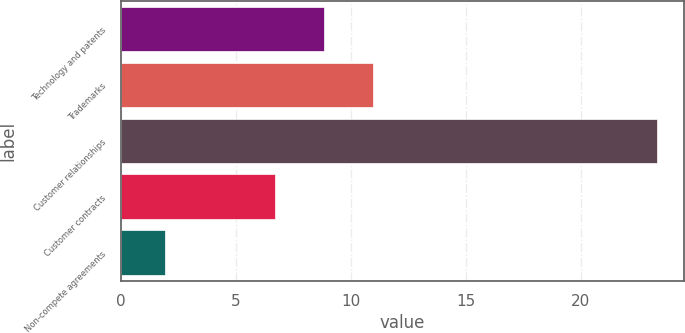Convert chart. <chart><loc_0><loc_0><loc_500><loc_500><bar_chart><fcel>Technology and patents<fcel>Trademarks<fcel>Customer relationships<fcel>Customer contracts<fcel>Non-compete agreements<nl><fcel>8.84<fcel>10.98<fcel>23.3<fcel>6.7<fcel>1.9<nl></chart> 